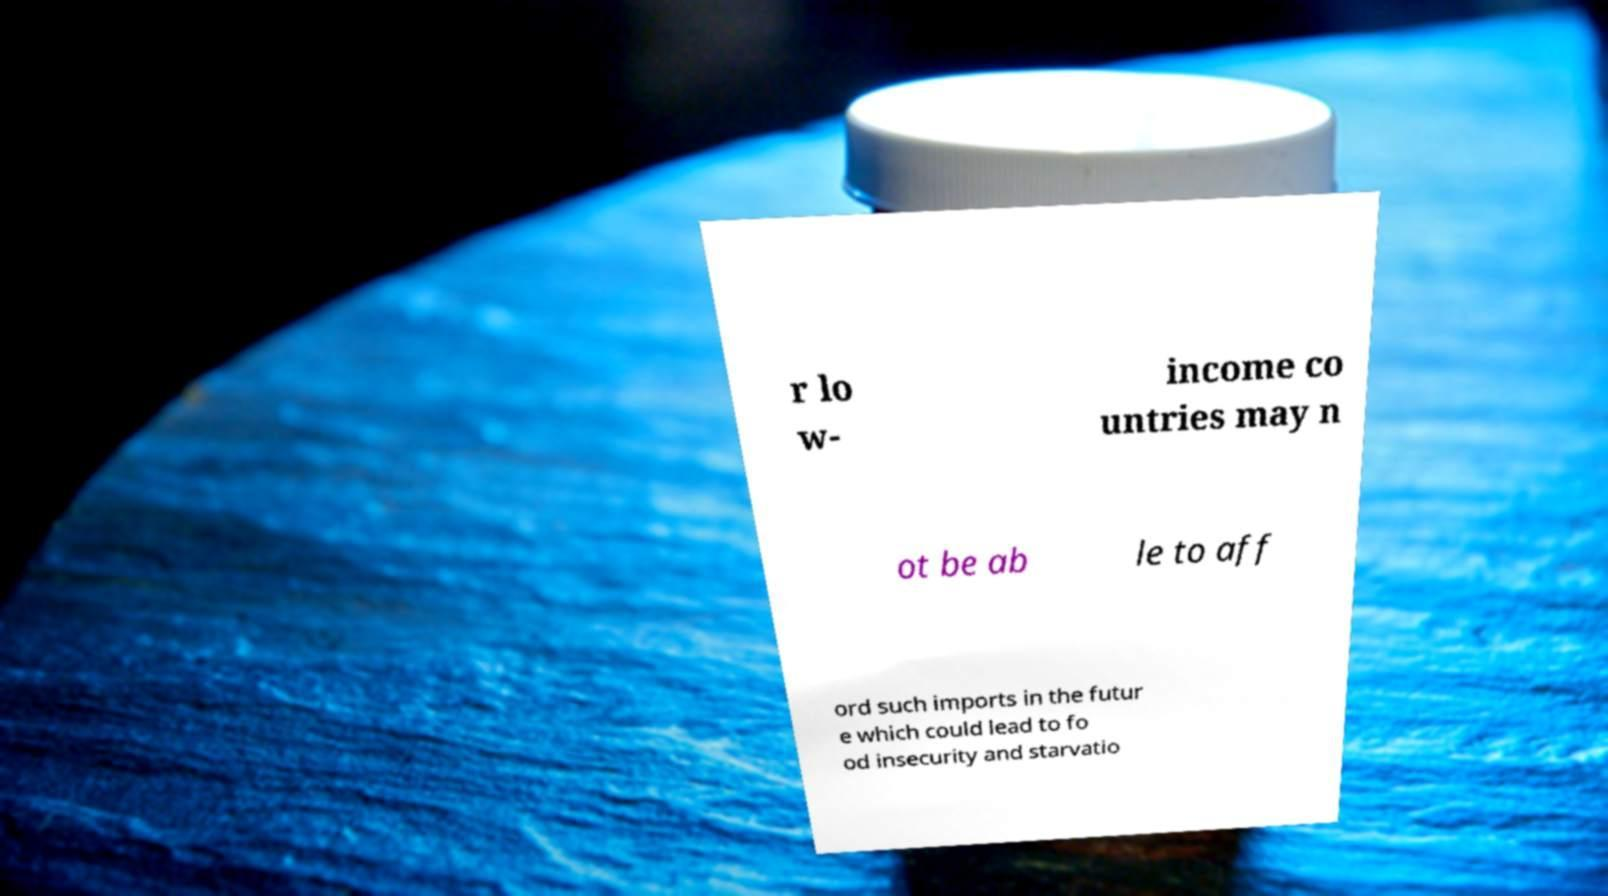What messages or text are displayed in this image? I need them in a readable, typed format. r lo w- income co untries may n ot be ab le to aff ord such imports in the futur e which could lead to fo od insecurity and starvatio 